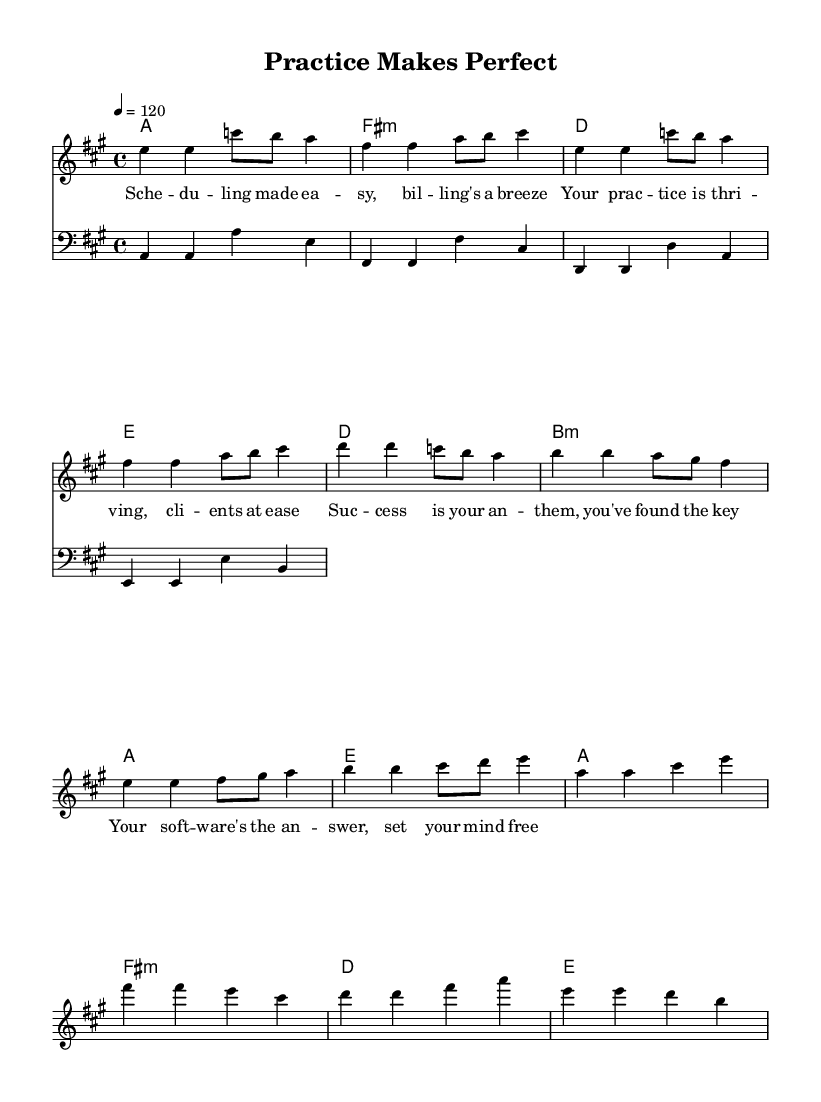What is the key signature of this music? The key signature indicates A major, which has three sharps (F#, C#, G#). This can be determined from the key signature markings at the beginning of the staff.
Answer: A major What is the time signature of this music? The time signature is 4/4, which means there are four beats in each measure and the quarter note gets one beat. This is usually found at the start of the score.
Answer: 4/4 What is the tempo marking of this song? The tempo marking is indicated as quarter note = 120, which means the quarter note should be played at a speed of 120 beats per minute. This is found at the start of the music section under the global settings.
Answer: 120 How many measures are in the song? Counting the measures in the given score, there are a total of 12 measures. This involves counting each vertical bar line in the sheet music.
Answer: 12 What is the first chord in the verse? The first chord is A major, which is indicated on the chord line above the melody staff at the start of the verse section.
Answer: A What is the lyric phrase in the chorus? The lyric phrase in the chorus is "Your soft -- ware's the an -- swer, set your mind free" found in the lyrics section aligned with the melody notes during the chorus part.
Answer: Your soft -- ware's the an -- swer, set your mind free Which section contains the pre-chorus? The pre-chorus section is identified specifically between the verse and chorus, with the respective melody notes and chords. This is typically marked in music by contrasting lyric placement and musical phrases.
Answer: Pre-chorus 